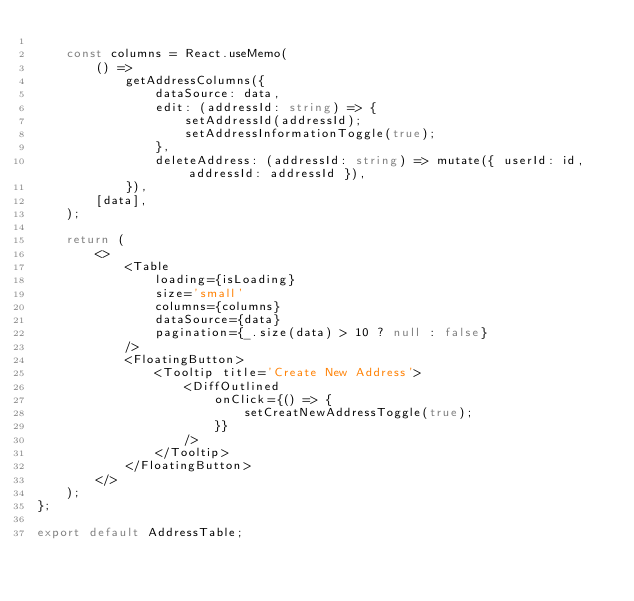<code> <loc_0><loc_0><loc_500><loc_500><_TypeScript_>
	const columns = React.useMemo(
		() =>
			getAddressColumns({
				dataSource: data,
				edit: (addressId: string) => {
					setAddressId(addressId);
					setAddressInformationToggle(true);
				},
				deleteAddress: (addressId: string) => mutate({ userId: id, addressId: addressId }),
			}),
		[data],
	);

	return (
		<>
			<Table
				loading={isLoading}
				size='small'
				columns={columns}
				dataSource={data}
				pagination={_.size(data) > 10 ? null : false}
			/>
			<FloatingButton>
				<Tooltip title='Create New Address'>
					<DiffOutlined
						onClick={() => {
							setCreatNewAddressToggle(true);
						}}
					/>
				</Tooltip>
			</FloatingButton>
		</>
	);
};

export default AddressTable;
</code> 